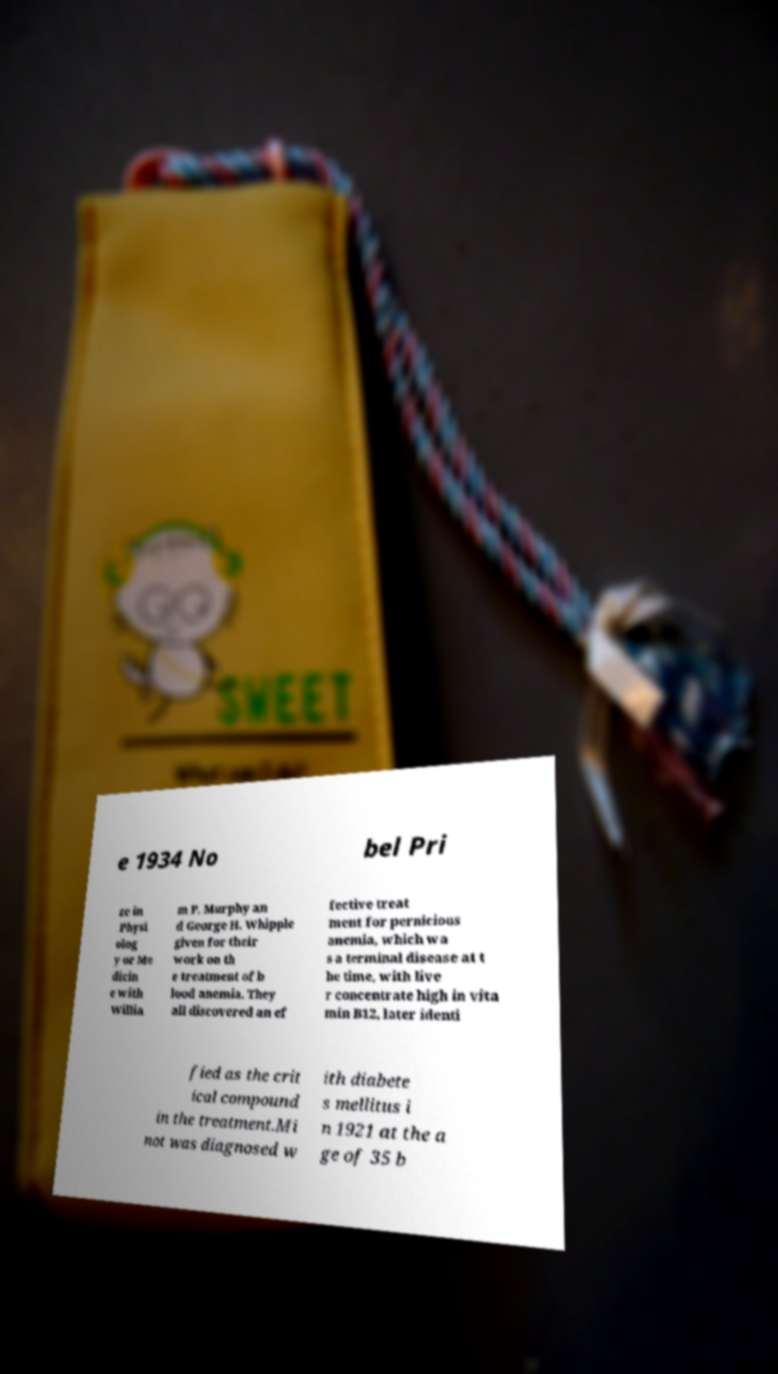I need the written content from this picture converted into text. Can you do that? e 1934 No bel Pri ze in Physi olog y or Me dicin e with Willia m P. Murphy an d George H. Whipple given for their work on th e treatment of b lood anemia. They all discovered an ef fective treat ment for pernicious anemia, which wa s a terminal disease at t he time, with live r concentrate high in vita min B12, later identi fied as the crit ical compound in the treatment.Mi not was diagnosed w ith diabete s mellitus i n 1921 at the a ge of 35 b 